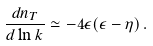Convert formula to latex. <formula><loc_0><loc_0><loc_500><loc_500>\frac { d n _ { T } } { d \ln k } \simeq - 4 \epsilon ( \epsilon - \eta ) \, .</formula> 